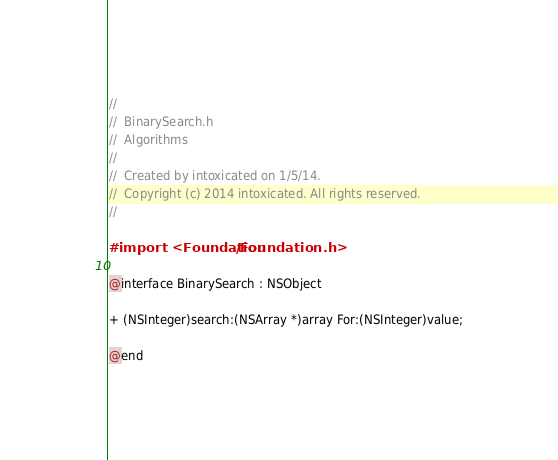Convert code to text. <code><loc_0><loc_0><loc_500><loc_500><_C_>//
//  BinarySearch.h
//  Algorithms
//
//  Created by intoxicated on 1/5/14.
//  Copyright (c) 2014 intoxicated. All rights reserved.
//

#import <Foundation/Foundation.h>

@interface BinarySearch : NSObject

+ (NSInteger)search:(NSArray *)array For:(NSInteger)value;

@end
</code> 